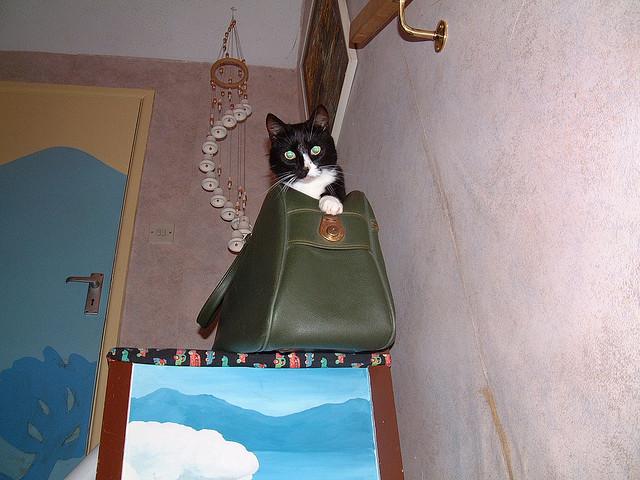Is that carpet on the walls?
Be succinct. Yes. Is this an appropriate bed for a cat?
Be succinct. No. What is the cat peeking out of?
Keep it brief. Purse. 